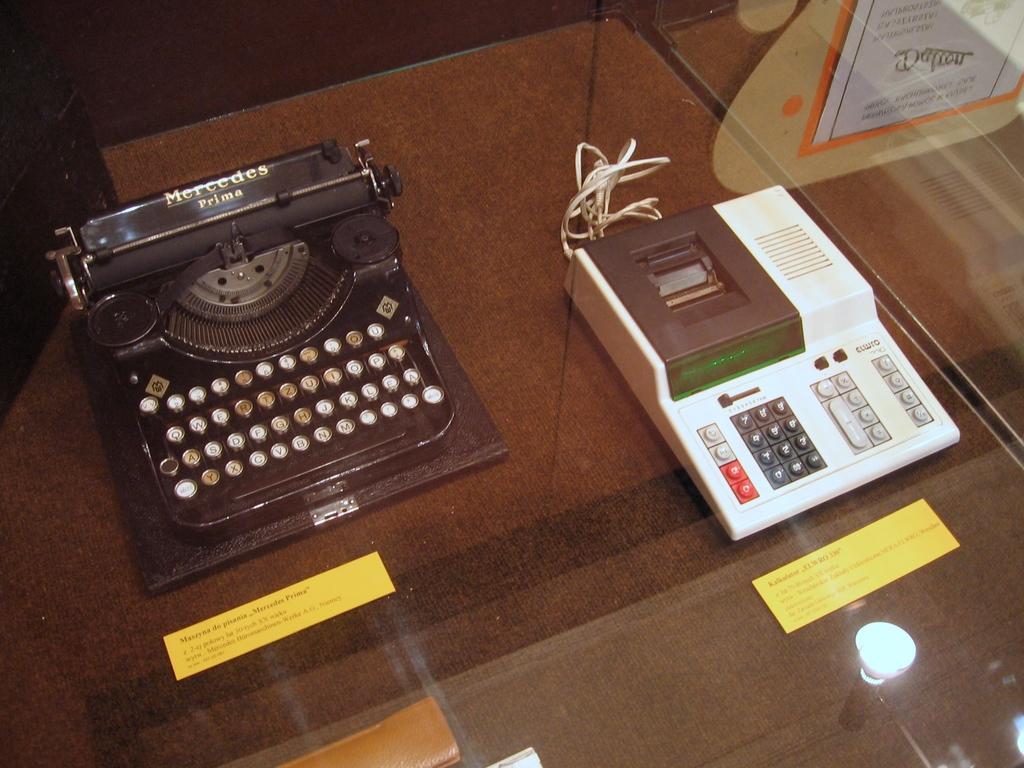Are these antique machines?
Give a very brief answer. Answering does not require reading text in the image. Atm card mechaine?
Offer a very short reply. Answering does not require reading text in the image. 